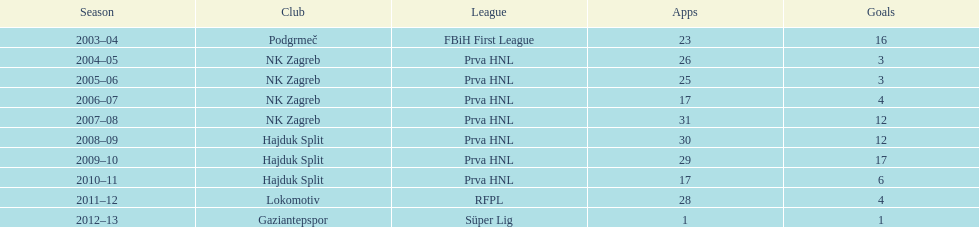Which team holds the record for the highest number of goals? Hajduk Split. 